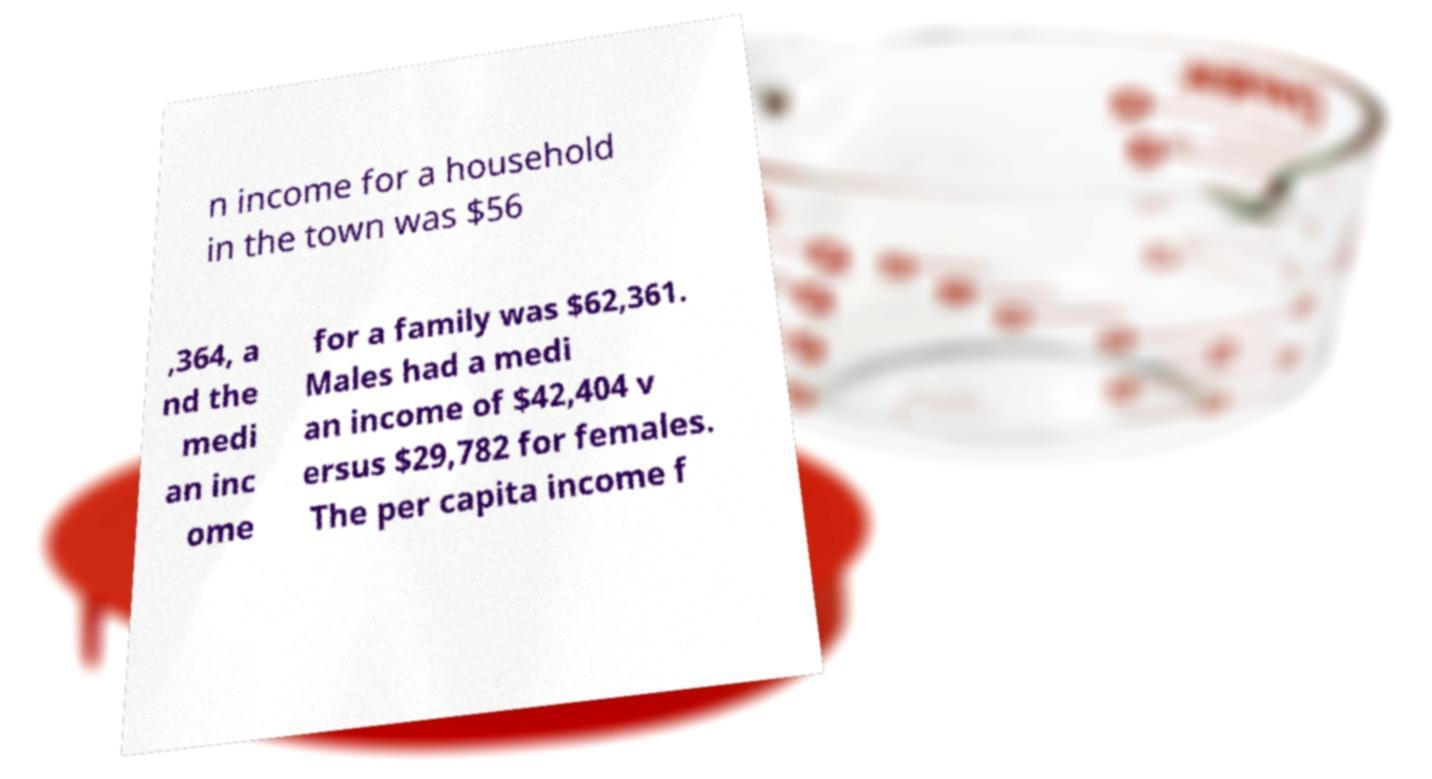There's text embedded in this image that I need extracted. Can you transcribe it verbatim? n income for a household in the town was $56 ,364, a nd the medi an inc ome for a family was $62,361. Males had a medi an income of $42,404 v ersus $29,782 for females. The per capita income f 